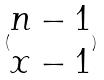<formula> <loc_0><loc_0><loc_500><loc_500>( \begin{matrix} n - 1 \\ x - 1 \end{matrix} )</formula> 